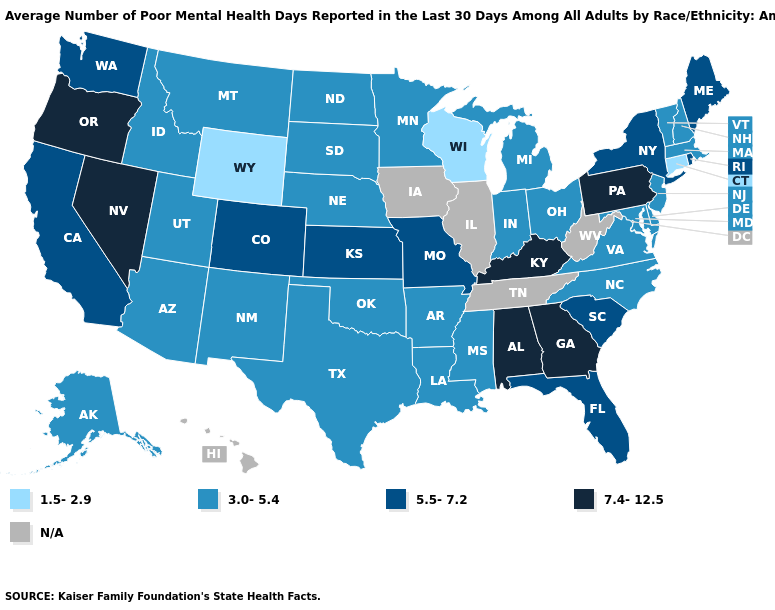How many symbols are there in the legend?
Answer briefly. 5. What is the highest value in states that border Alabama?
Answer briefly. 7.4-12.5. Name the states that have a value in the range N/A?
Write a very short answer. Hawaii, Illinois, Iowa, Tennessee, West Virginia. Among the states that border New Jersey , does Delaware have the highest value?
Answer briefly. No. Name the states that have a value in the range N/A?
Answer briefly. Hawaii, Illinois, Iowa, Tennessee, West Virginia. Name the states that have a value in the range 3.0-5.4?
Concise answer only. Alaska, Arizona, Arkansas, Delaware, Idaho, Indiana, Louisiana, Maryland, Massachusetts, Michigan, Minnesota, Mississippi, Montana, Nebraska, New Hampshire, New Jersey, New Mexico, North Carolina, North Dakota, Ohio, Oklahoma, South Dakota, Texas, Utah, Vermont, Virginia. What is the lowest value in the Northeast?
Be succinct. 1.5-2.9. Which states hav the highest value in the South?
Quick response, please. Alabama, Georgia, Kentucky. Name the states that have a value in the range N/A?
Concise answer only. Hawaii, Illinois, Iowa, Tennessee, West Virginia. Name the states that have a value in the range N/A?
Quick response, please. Hawaii, Illinois, Iowa, Tennessee, West Virginia. Among the states that border New Mexico , does Texas have the highest value?
Short answer required. No. Does the first symbol in the legend represent the smallest category?
Quick response, please. Yes. Which states have the highest value in the USA?
Quick response, please. Alabama, Georgia, Kentucky, Nevada, Oregon, Pennsylvania. What is the lowest value in the West?
Be succinct. 1.5-2.9. What is the value of Pennsylvania?
Write a very short answer. 7.4-12.5. 